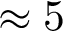Convert formula to latex. <formula><loc_0><loc_0><loc_500><loc_500>\approx 5</formula> 